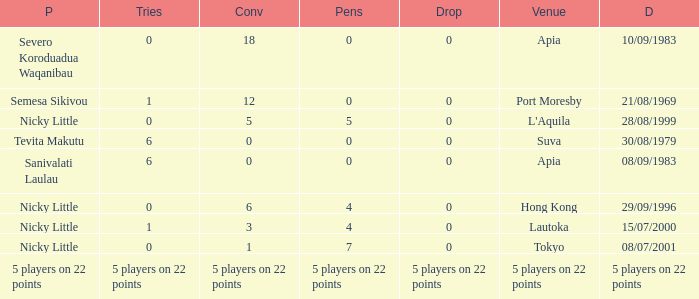Give me the full table as a dictionary. {'header': ['P', 'Tries', 'Conv', 'Pens', 'Drop', 'Venue', 'D'], 'rows': [['Severo Koroduadua Waqanibau', '0', '18', '0', '0', 'Apia', '10/09/1983'], ['Semesa Sikivou', '1', '12', '0', '0', 'Port Moresby', '21/08/1969'], ['Nicky Little', '0', '5', '5', '0', "L'Aquila", '28/08/1999'], ['Tevita Makutu', '6', '0', '0', '0', 'Suva', '30/08/1979'], ['Sanivalati Laulau', '6', '0', '0', '0', 'Apia', '08/09/1983'], ['Nicky Little', '0', '6', '4', '0', 'Hong Kong', '29/09/1996'], ['Nicky Little', '1', '3', '4', '0', 'Lautoka', '15/07/2000'], ['Nicky Little', '0', '1', '7', '0', 'Tokyo', '08/07/2001'], ['5 players on 22 points', '5 players on 22 points', '5 players on 22 points', '5 players on 22 points', '5 players on 22 points', '5 players on 22 points', '5 players on 22 points']]} How many conversions had 0 pens and 0 tries? 18.0. 